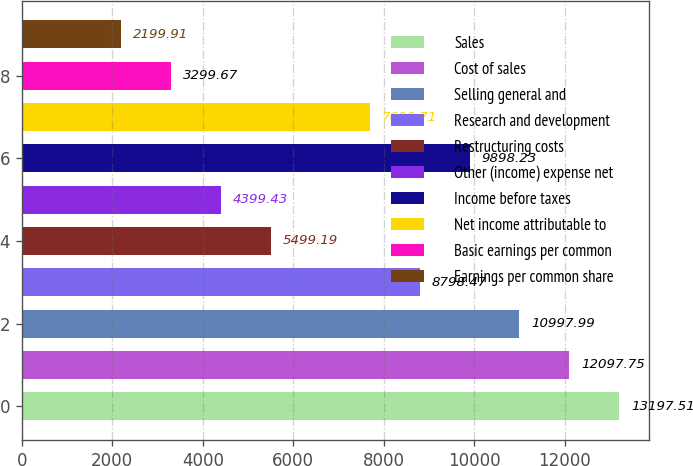<chart> <loc_0><loc_0><loc_500><loc_500><bar_chart><fcel>Sales<fcel>Cost of sales<fcel>Selling general and<fcel>Research and development<fcel>Restructuring costs<fcel>Other (income) expense net<fcel>Income before taxes<fcel>Net income attributable to<fcel>Basic earnings per common<fcel>Earnings per common share<nl><fcel>13197.5<fcel>12097.8<fcel>10998<fcel>8798.47<fcel>5499.19<fcel>4399.43<fcel>9898.23<fcel>7698.71<fcel>3299.67<fcel>2199.91<nl></chart> 